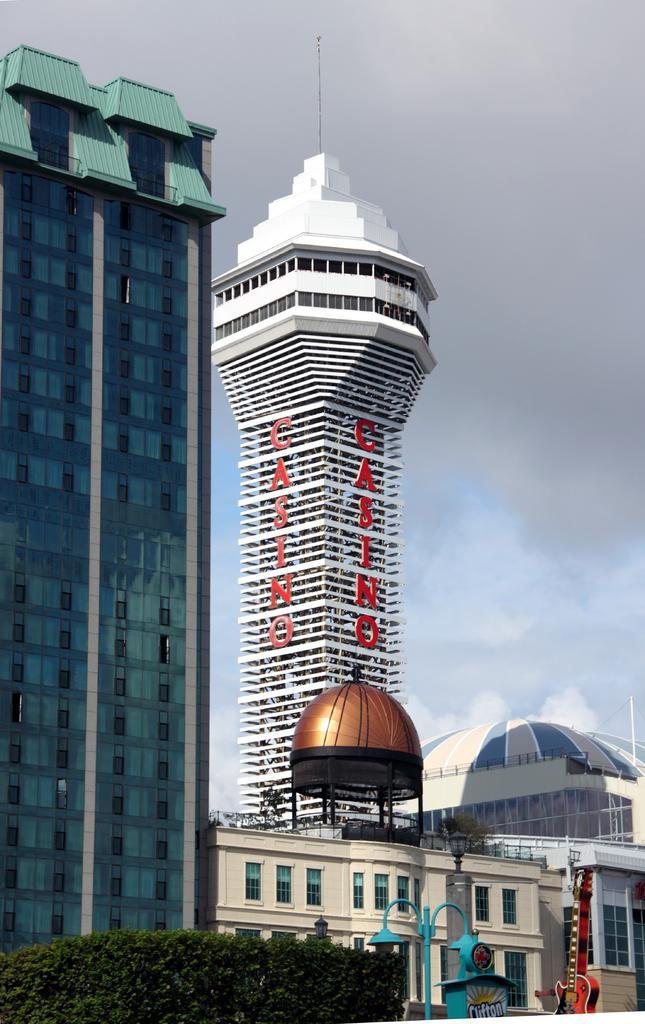In one or two sentences, can you explain what this image depicts? In the image there is a tall building and beside that there is a tower and there are some plants in the foreground and beside the plants there is a pole and beside that there is some object in the shape of a guitar. 